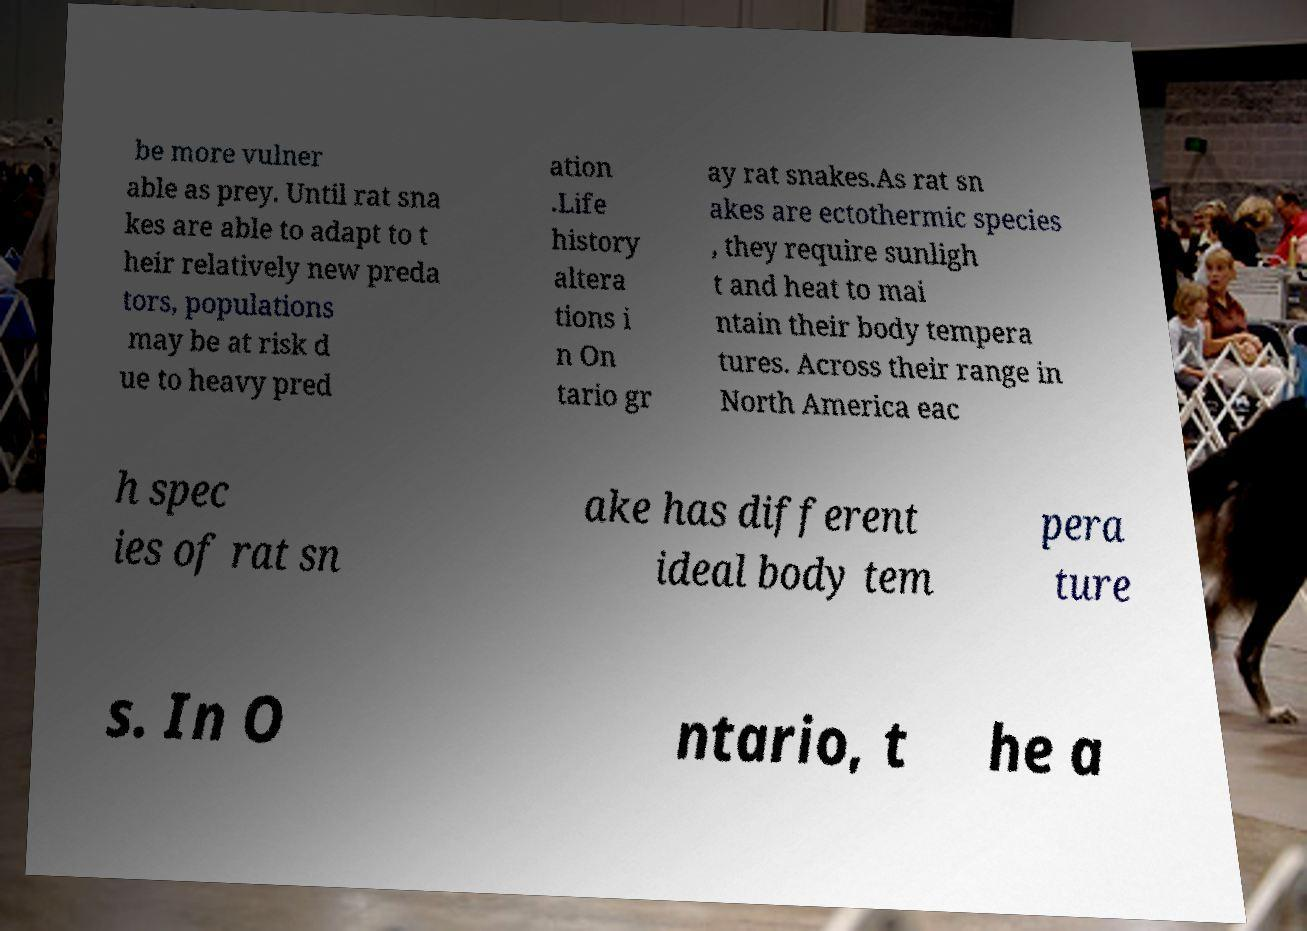For documentation purposes, I need the text within this image transcribed. Could you provide that? be more vulner able as prey. Until rat sna kes are able to adapt to t heir relatively new preda tors, populations may be at risk d ue to heavy pred ation .Life history altera tions i n On tario gr ay rat snakes.As rat sn akes are ectothermic species , they require sunligh t and heat to mai ntain their body tempera tures. Across their range in North America eac h spec ies of rat sn ake has different ideal body tem pera ture s. In O ntario, t he a 